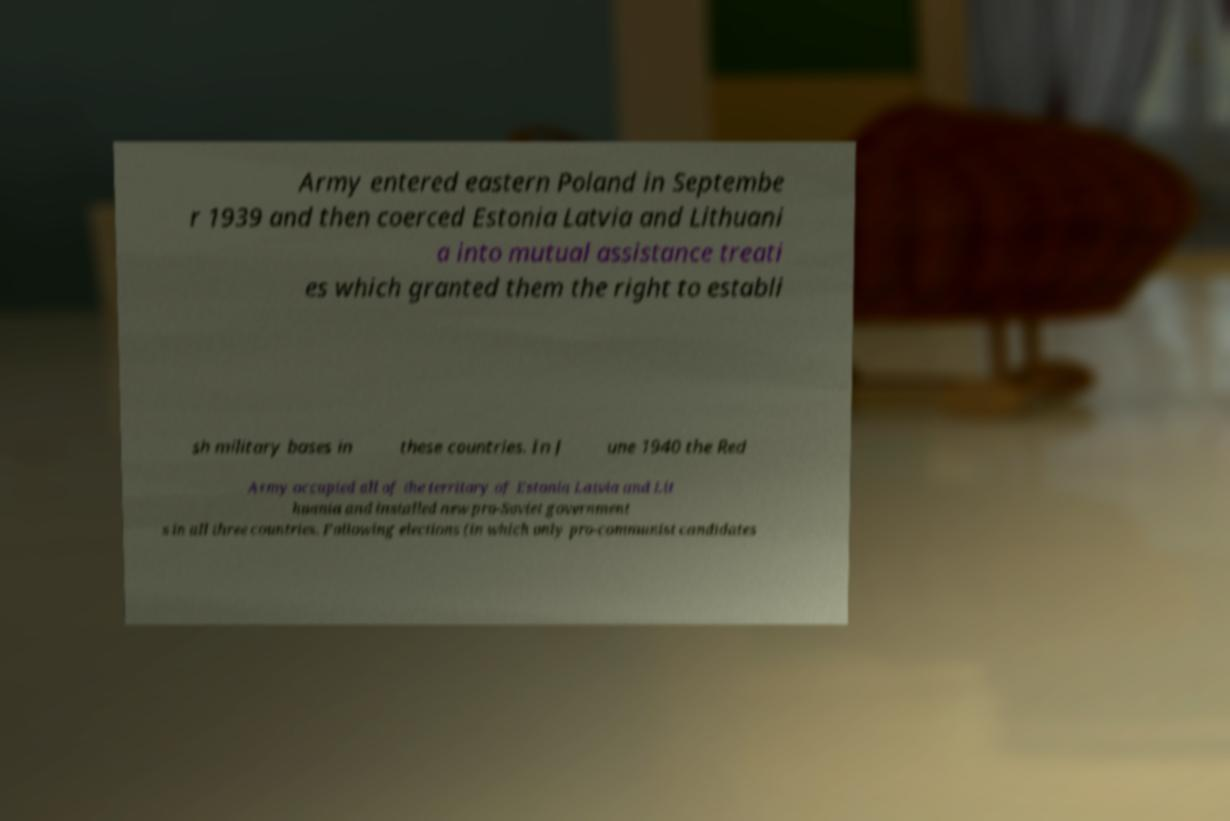Can you read and provide the text displayed in the image?This photo seems to have some interesting text. Can you extract and type it out for me? Army entered eastern Poland in Septembe r 1939 and then coerced Estonia Latvia and Lithuani a into mutual assistance treati es which granted them the right to establi sh military bases in these countries. In J une 1940 the Red Army occupied all of the territory of Estonia Latvia and Lit huania and installed new pro-Soviet government s in all three countries. Following elections (in which only pro-communist candidates 